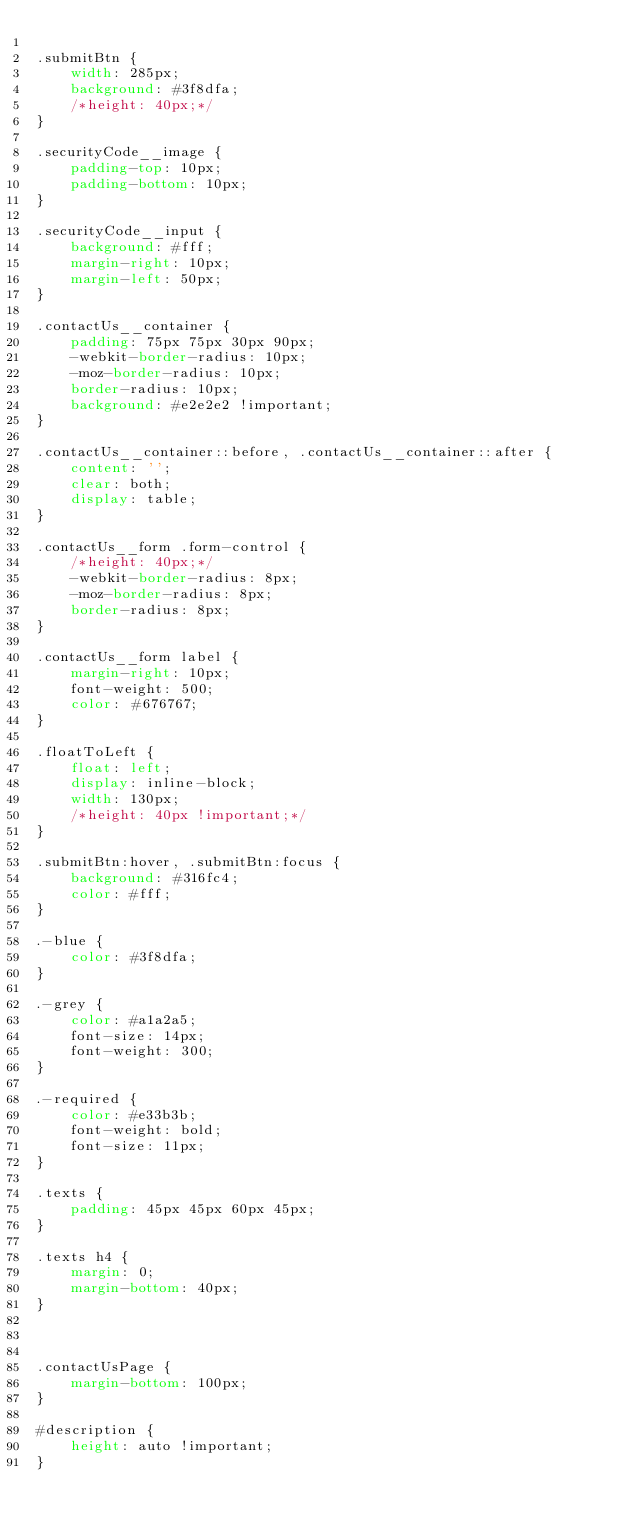Convert code to text. <code><loc_0><loc_0><loc_500><loc_500><_CSS_>
.submitBtn {
    width: 285px;
    background: #3f8dfa;
    /*height: 40px;*/
}

.securityCode__image {
    padding-top: 10px;
    padding-bottom: 10px;
}

.securityCode__input {
    background: #fff;
    margin-right: 10px;
    margin-left: 50px;
}

.contactUs__container {
    padding: 75px 75px 30px 90px;
    -webkit-border-radius: 10px;
    -moz-border-radius: 10px;
    border-radius: 10px;
    background: #e2e2e2 !important;
}

.contactUs__container::before, .contactUs__container::after {
    content: '';
    clear: both;
    display: table;
}

.contactUs__form .form-control {
    /*height: 40px;*/
    -webkit-border-radius: 8px;
    -moz-border-radius: 8px;
    border-radius: 8px;
}

.contactUs__form label {
    margin-right: 10px;
    font-weight: 500;
    color: #676767;
}

.floatToLeft {
    float: left;
    display: inline-block;
    width: 130px;
    /*height: 40px !important;*/
}

.submitBtn:hover, .submitBtn:focus {
    background: #316fc4;
    color: #fff;
}

.-blue {
    color: #3f8dfa;
}

.-grey {
    color: #a1a2a5;
    font-size: 14px;
    font-weight: 300;
}

.-required {
    color: #e33b3b;
    font-weight: bold;
    font-size: 11px;
}

.texts {
    padding: 45px 45px 60px 45px;
}

.texts h4 {
    margin: 0;
    margin-bottom: 40px;
}



.contactUsPage {
    margin-bottom: 100px;
}

#description {
    height: auto !important;
}</code> 